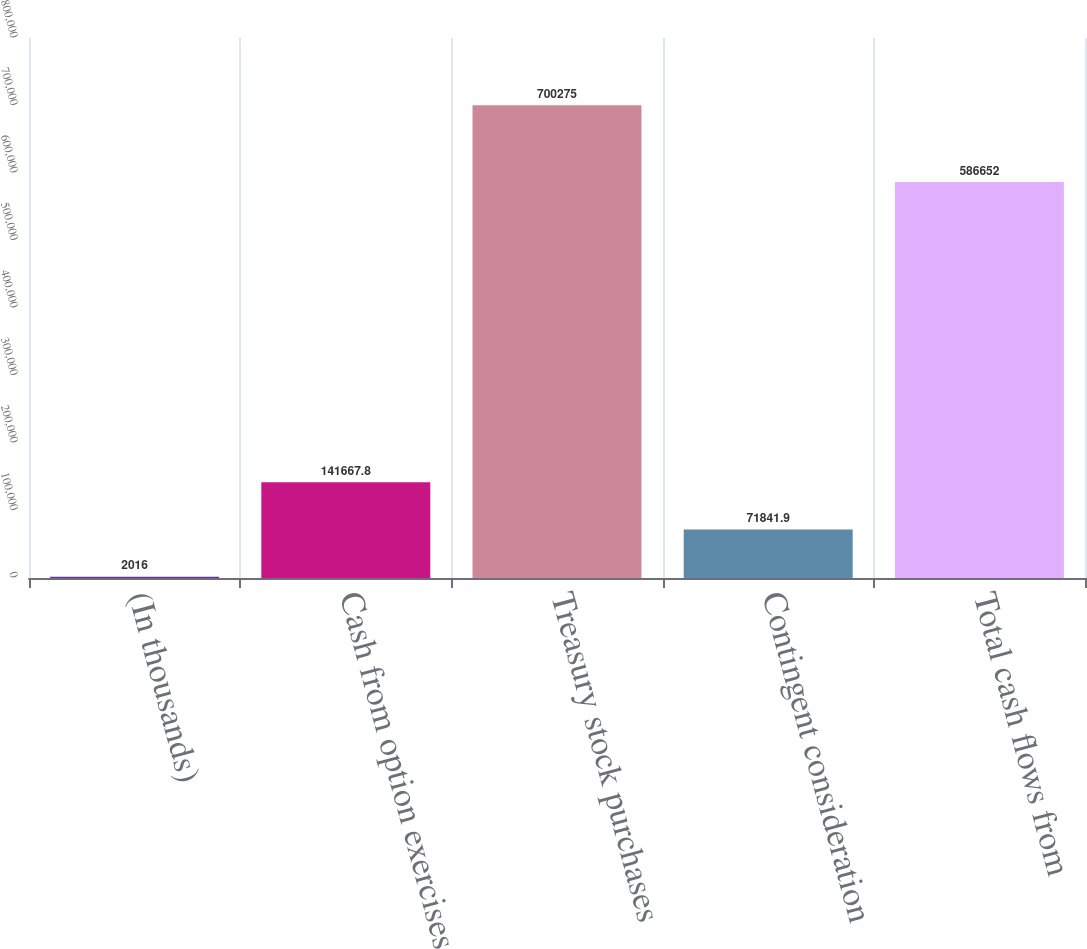Convert chart to OTSL. <chart><loc_0><loc_0><loc_500><loc_500><bar_chart><fcel>(In thousands)<fcel>Cash from option exercises<fcel>Treasury stock purchases<fcel>Contingent consideration<fcel>Total cash flows from<nl><fcel>2016<fcel>141668<fcel>700275<fcel>71841.9<fcel>586652<nl></chart> 